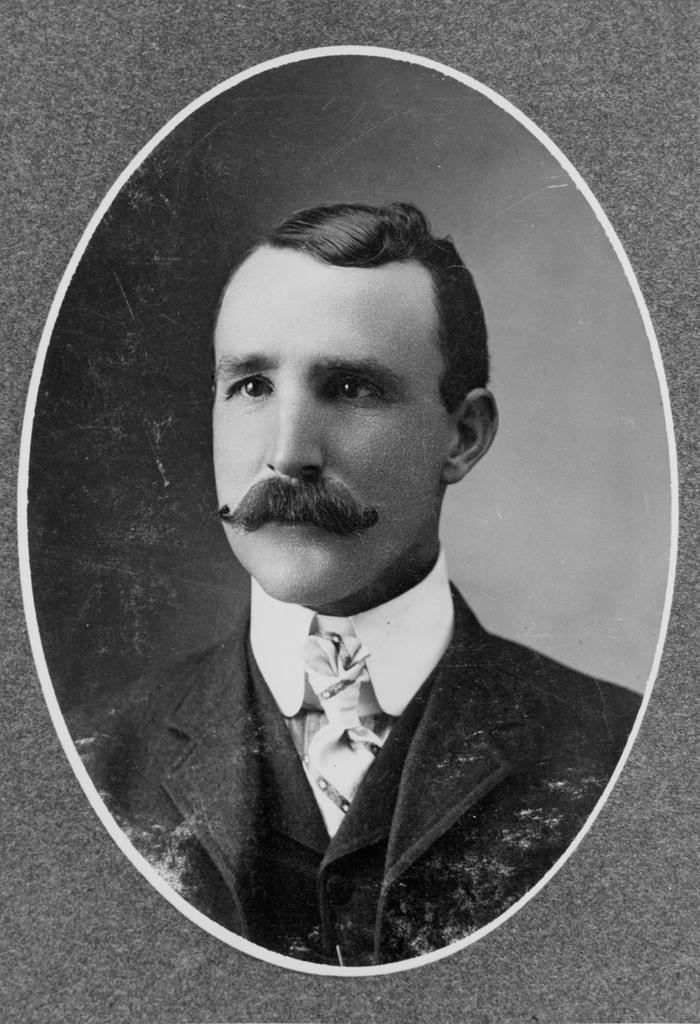Describe this image in one or two sentences. This image consists of a photo frame with a picture of a man on it. 